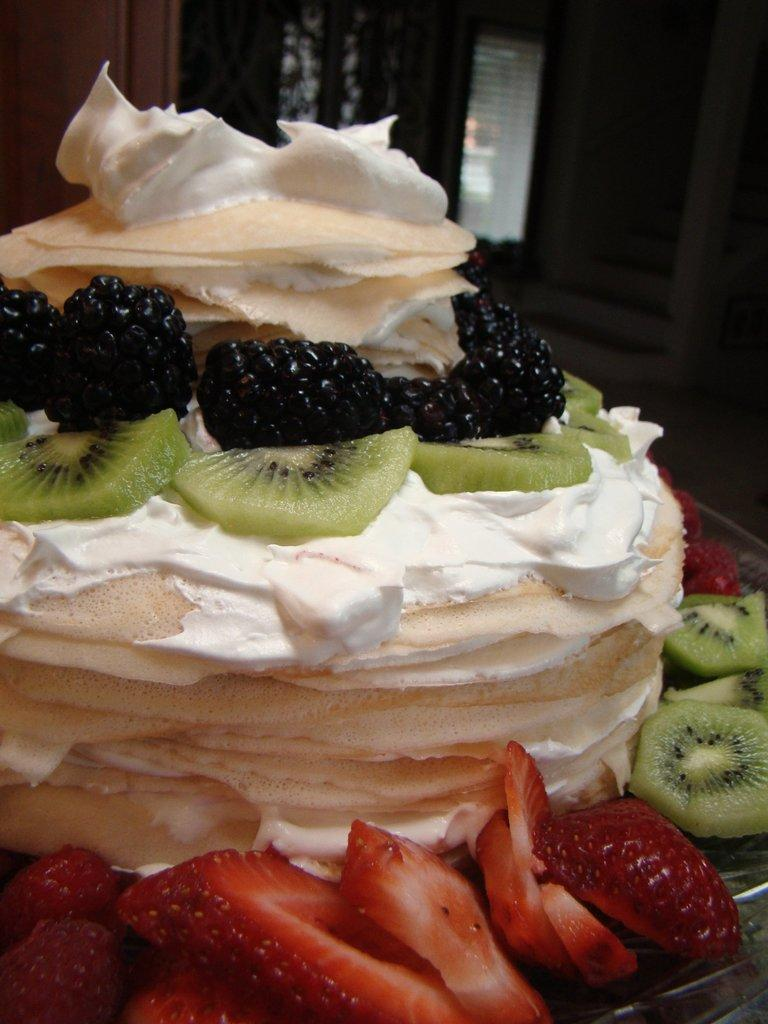What is the main subject of the image? There is a cake in the image. What type of fruits can be seen on the cake? The cake has strawberries and Kiwi on it, as well as other fruits. What is the texture of the cake? The cake has cream on it, which suggests a creamy texture. What can be seen in the background of the image? There is a door visible in the background of the image. What flavor of current is used in the cake? There is no current present in the image, as it is a cake with fruits and cream. 